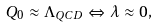Convert formula to latex. <formula><loc_0><loc_0><loc_500><loc_500>Q _ { 0 } \approx \Lambda _ { Q C D } \Leftrightarrow \lambda \approx 0 ,</formula> 